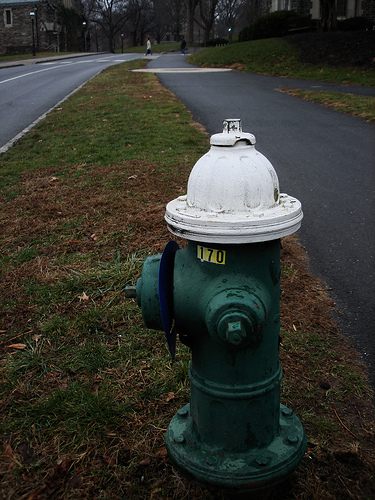Please provide the bounding box coordinate of the region this sentence describes: Blue disc on fire hydrant. The blue disc on the fire hydrant can be accurately bounded by the coordinates [0.44, 0.45, 0.49, 0.73]. This part typically stands out due to its vibrant color, which serves both aesthetic and functional purposes. 